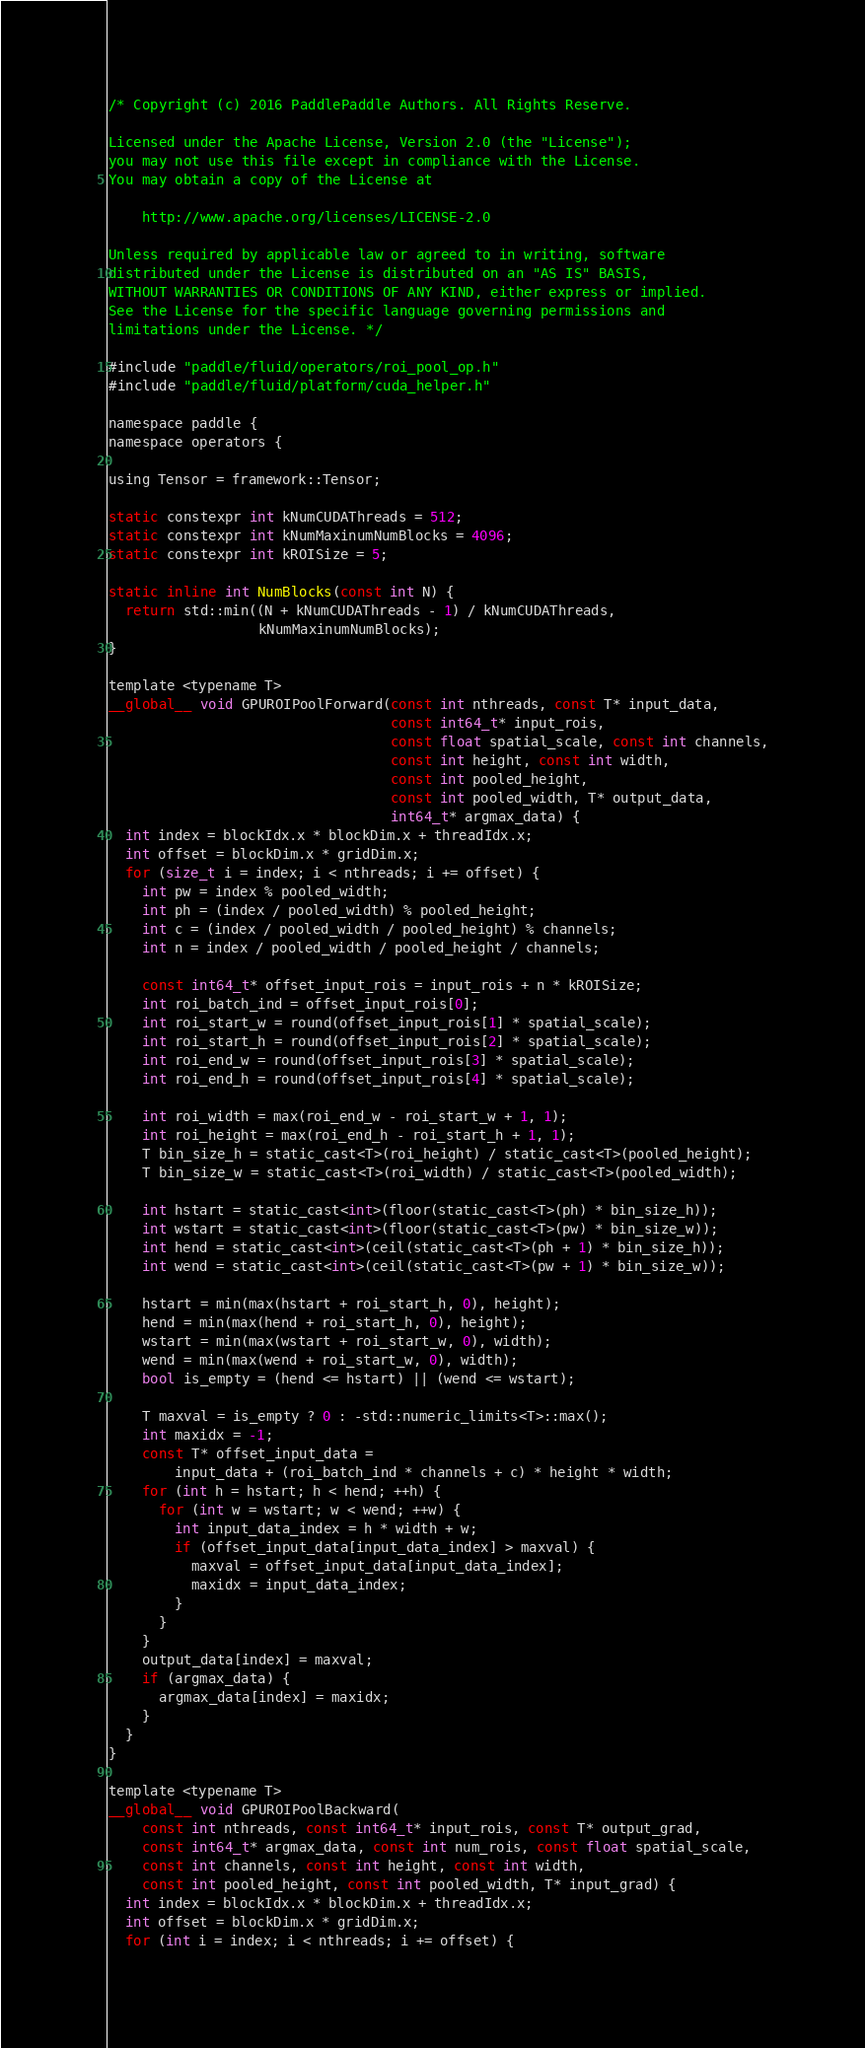Convert code to text. <code><loc_0><loc_0><loc_500><loc_500><_Cuda_>/* Copyright (c) 2016 PaddlePaddle Authors. All Rights Reserve.

Licensed under the Apache License, Version 2.0 (the "License");
you may not use this file except in compliance with the License.
You may obtain a copy of the License at

    http://www.apache.org/licenses/LICENSE-2.0

Unless required by applicable law or agreed to in writing, software
distributed under the License is distributed on an "AS IS" BASIS,
WITHOUT WARRANTIES OR CONDITIONS OF ANY KIND, either express or implied.
See the License for the specific language governing permissions and
limitations under the License. */

#include "paddle/fluid/operators/roi_pool_op.h"
#include "paddle/fluid/platform/cuda_helper.h"

namespace paddle {
namespace operators {

using Tensor = framework::Tensor;

static constexpr int kNumCUDAThreads = 512;
static constexpr int kNumMaxinumNumBlocks = 4096;
static constexpr int kROISize = 5;

static inline int NumBlocks(const int N) {
  return std::min((N + kNumCUDAThreads - 1) / kNumCUDAThreads,
                  kNumMaxinumNumBlocks);
}

template <typename T>
__global__ void GPUROIPoolForward(const int nthreads, const T* input_data,
                                  const int64_t* input_rois,
                                  const float spatial_scale, const int channels,
                                  const int height, const int width,
                                  const int pooled_height,
                                  const int pooled_width, T* output_data,
                                  int64_t* argmax_data) {
  int index = blockIdx.x * blockDim.x + threadIdx.x;
  int offset = blockDim.x * gridDim.x;
  for (size_t i = index; i < nthreads; i += offset) {
    int pw = index % pooled_width;
    int ph = (index / pooled_width) % pooled_height;
    int c = (index / pooled_width / pooled_height) % channels;
    int n = index / pooled_width / pooled_height / channels;

    const int64_t* offset_input_rois = input_rois + n * kROISize;
    int roi_batch_ind = offset_input_rois[0];
    int roi_start_w = round(offset_input_rois[1] * spatial_scale);
    int roi_start_h = round(offset_input_rois[2] * spatial_scale);
    int roi_end_w = round(offset_input_rois[3] * spatial_scale);
    int roi_end_h = round(offset_input_rois[4] * spatial_scale);

    int roi_width = max(roi_end_w - roi_start_w + 1, 1);
    int roi_height = max(roi_end_h - roi_start_h + 1, 1);
    T bin_size_h = static_cast<T>(roi_height) / static_cast<T>(pooled_height);
    T bin_size_w = static_cast<T>(roi_width) / static_cast<T>(pooled_width);

    int hstart = static_cast<int>(floor(static_cast<T>(ph) * bin_size_h));
    int wstart = static_cast<int>(floor(static_cast<T>(pw) * bin_size_w));
    int hend = static_cast<int>(ceil(static_cast<T>(ph + 1) * bin_size_h));
    int wend = static_cast<int>(ceil(static_cast<T>(pw + 1) * bin_size_w));

    hstart = min(max(hstart + roi_start_h, 0), height);
    hend = min(max(hend + roi_start_h, 0), height);
    wstart = min(max(wstart + roi_start_w, 0), width);
    wend = min(max(wend + roi_start_w, 0), width);
    bool is_empty = (hend <= hstart) || (wend <= wstart);

    T maxval = is_empty ? 0 : -std::numeric_limits<T>::max();
    int maxidx = -1;
    const T* offset_input_data =
        input_data + (roi_batch_ind * channels + c) * height * width;
    for (int h = hstart; h < hend; ++h) {
      for (int w = wstart; w < wend; ++w) {
        int input_data_index = h * width + w;
        if (offset_input_data[input_data_index] > maxval) {
          maxval = offset_input_data[input_data_index];
          maxidx = input_data_index;
        }
      }
    }
    output_data[index] = maxval;
    if (argmax_data) {
      argmax_data[index] = maxidx;
    }
  }
}

template <typename T>
__global__ void GPUROIPoolBackward(
    const int nthreads, const int64_t* input_rois, const T* output_grad,
    const int64_t* argmax_data, const int num_rois, const float spatial_scale,
    const int channels, const int height, const int width,
    const int pooled_height, const int pooled_width, T* input_grad) {
  int index = blockIdx.x * blockDim.x + threadIdx.x;
  int offset = blockDim.x * gridDim.x;
  for (int i = index; i < nthreads; i += offset) {</code> 